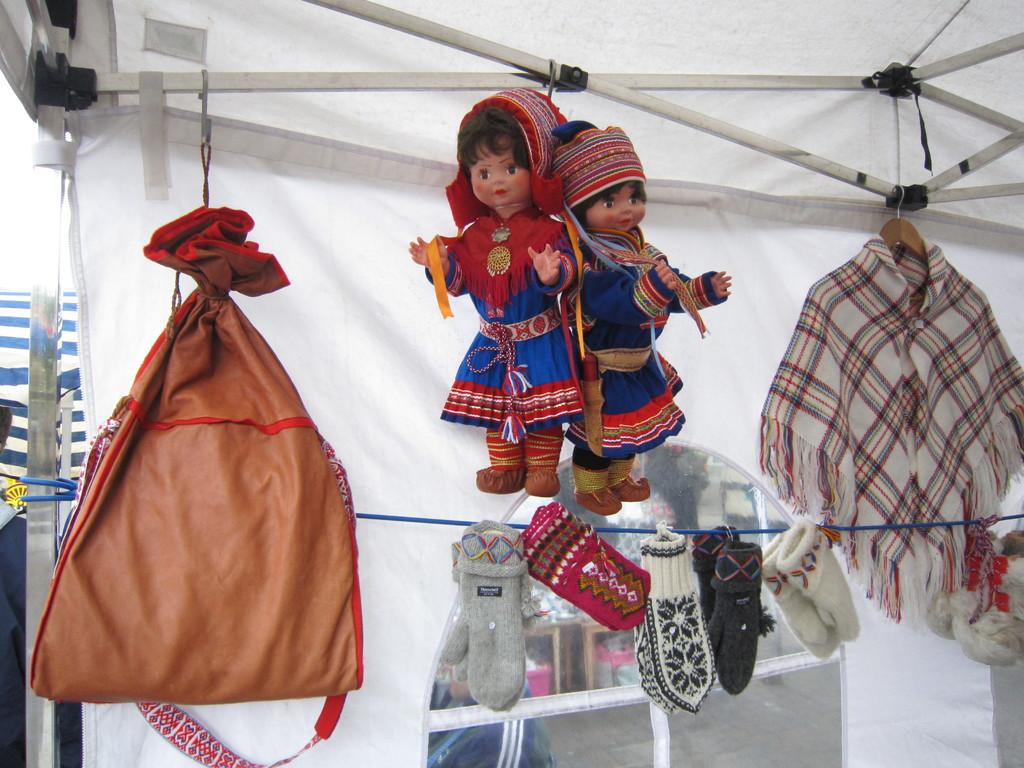How many dolls are present in the image? There are 2 dolls in the image. What else can be seen in the image besides the dolls? There is a bag, a cloth, socks hanged on a rope, a tent in the background, metal rods in the background, and the sky visible in the background. What type of water can be seen in the image? There is no water present in the image. What school-related items can be seen in the image? There are no school-related items present in the image. 